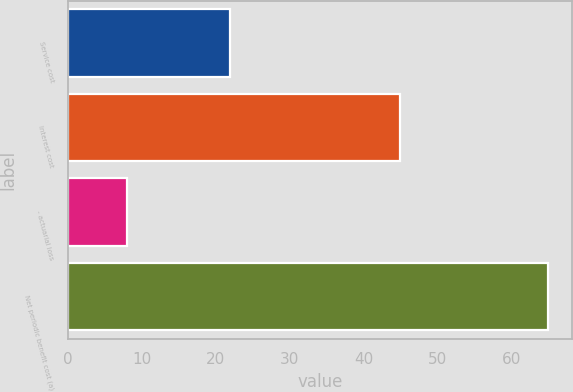Convert chart to OTSL. <chart><loc_0><loc_0><loc_500><loc_500><bar_chart><fcel>Service cost<fcel>Interest cost<fcel>- actuarial loss<fcel>Net periodic benefit cost (a)<nl><fcel>22<fcel>45<fcel>8<fcel>65<nl></chart> 